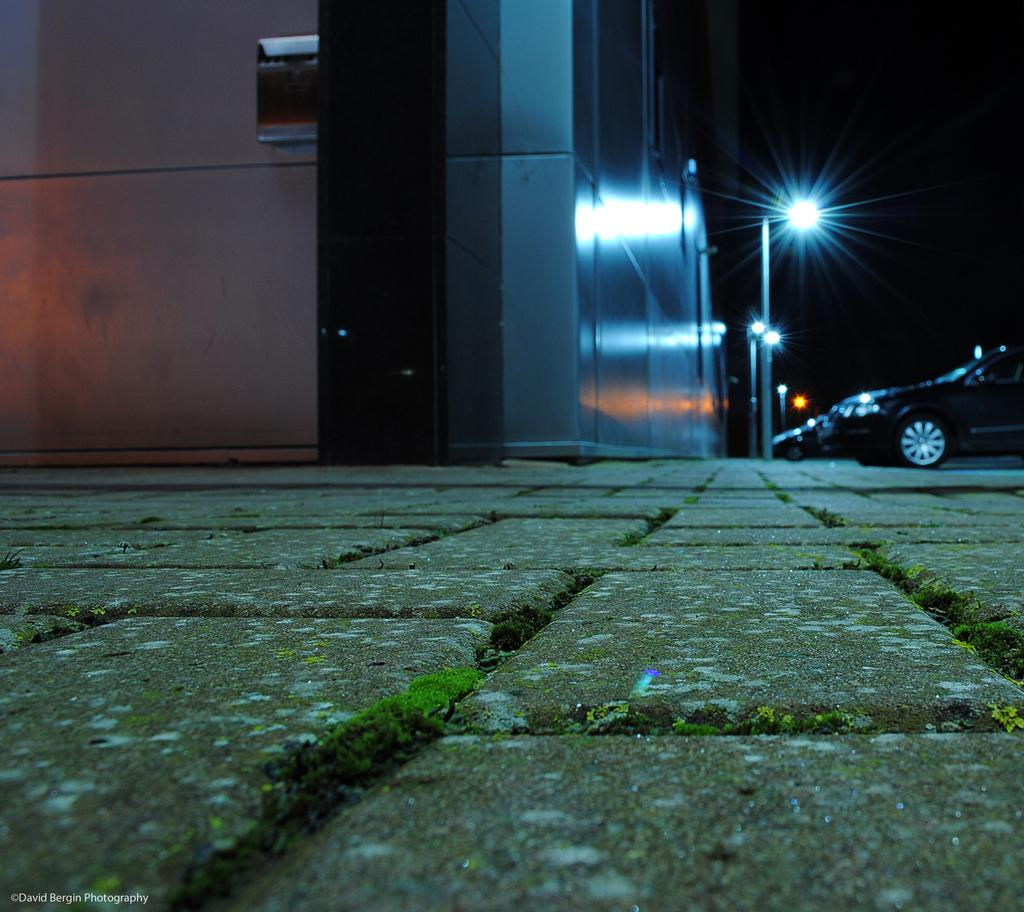What type of vegetation is at the bottom of the image? There is grass at the bottom of the image. What structure is located on the left side of the image? There is a building on the left side of the image. What type of vehicle is on the right side of the image? There is a car on the right side of the image. What other objects are on the right side of the image? There are poles and lights on the right side of the image. How would you describe the overall lighting in the image? The background of the image is dark. What color is the paint on the grass in the image? There is no paint on the grass in the image; it is natural vegetation. What advice does the mom give in the image? There is no mom present in the image, so no advice can be given. 